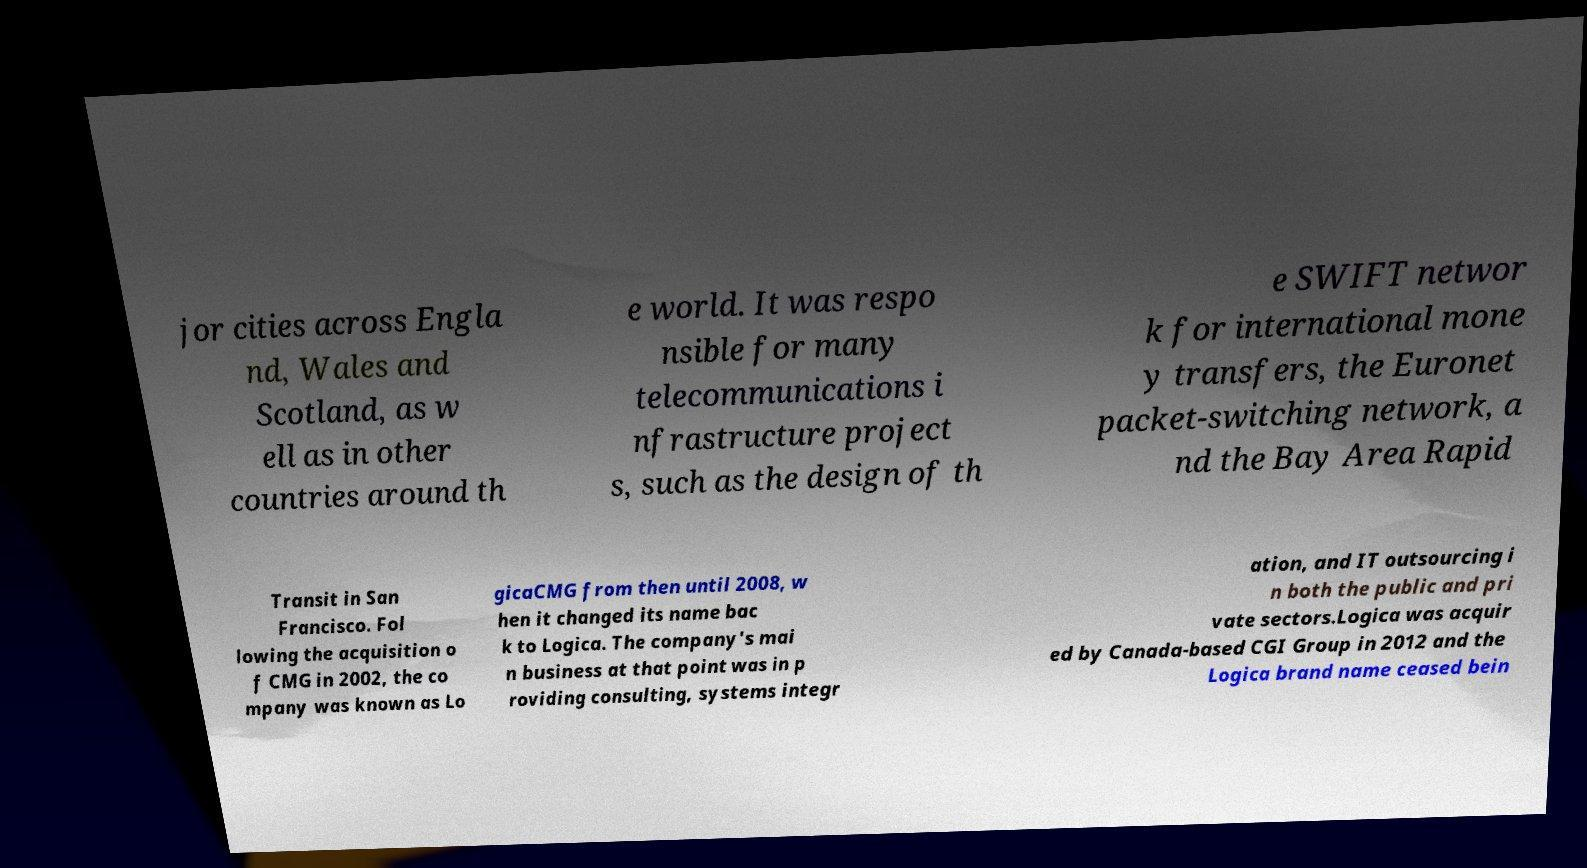Can you read and provide the text displayed in the image?This photo seems to have some interesting text. Can you extract and type it out for me? jor cities across Engla nd, Wales and Scotland, as w ell as in other countries around th e world. It was respo nsible for many telecommunications i nfrastructure project s, such as the design of th e SWIFT networ k for international mone y transfers, the Euronet packet-switching network, a nd the Bay Area Rapid Transit in San Francisco. Fol lowing the acquisition o f CMG in 2002, the co mpany was known as Lo gicaCMG from then until 2008, w hen it changed its name bac k to Logica. The company's mai n business at that point was in p roviding consulting, systems integr ation, and IT outsourcing i n both the public and pri vate sectors.Logica was acquir ed by Canada-based CGI Group in 2012 and the Logica brand name ceased bein 